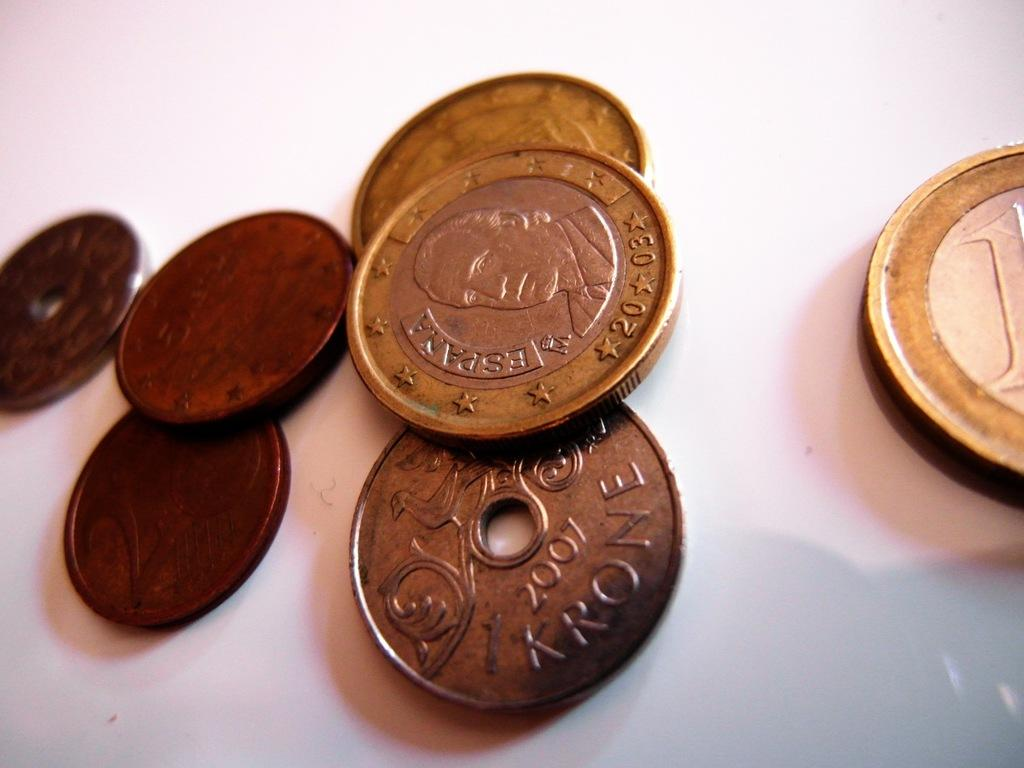<image>
Share a concise interpretation of the image provided. An old coin with a Espana label on it is on the table with some other coins. 